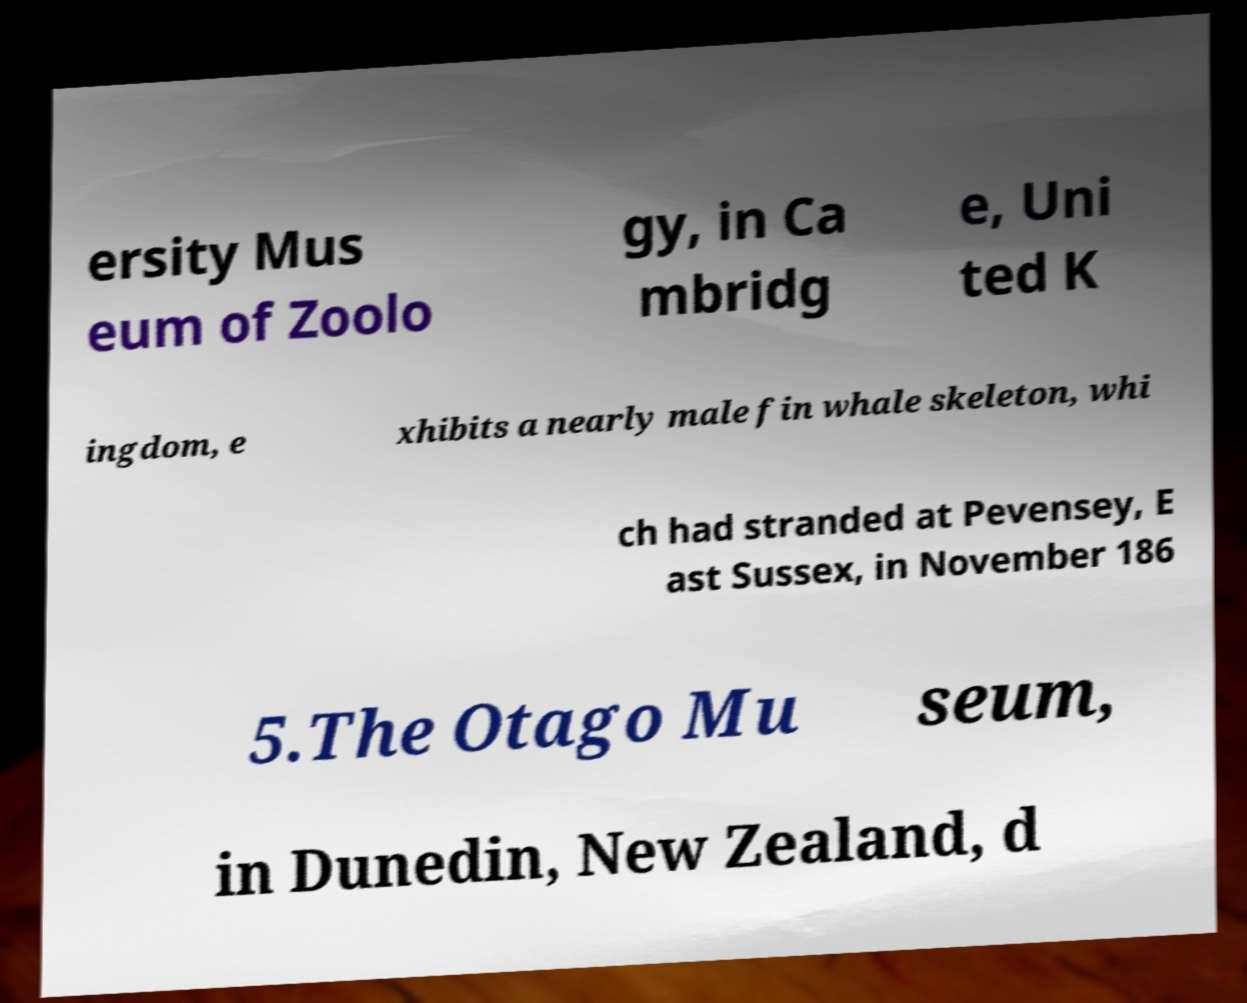I need the written content from this picture converted into text. Can you do that? ersity Mus eum of Zoolo gy, in Ca mbridg e, Uni ted K ingdom, e xhibits a nearly male fin whale skeleton, whi ch had stranded at Pevensey, E ast Sussex, in November 186 5.The Otago Mu seum, in Dunedin, New Zealand, d 